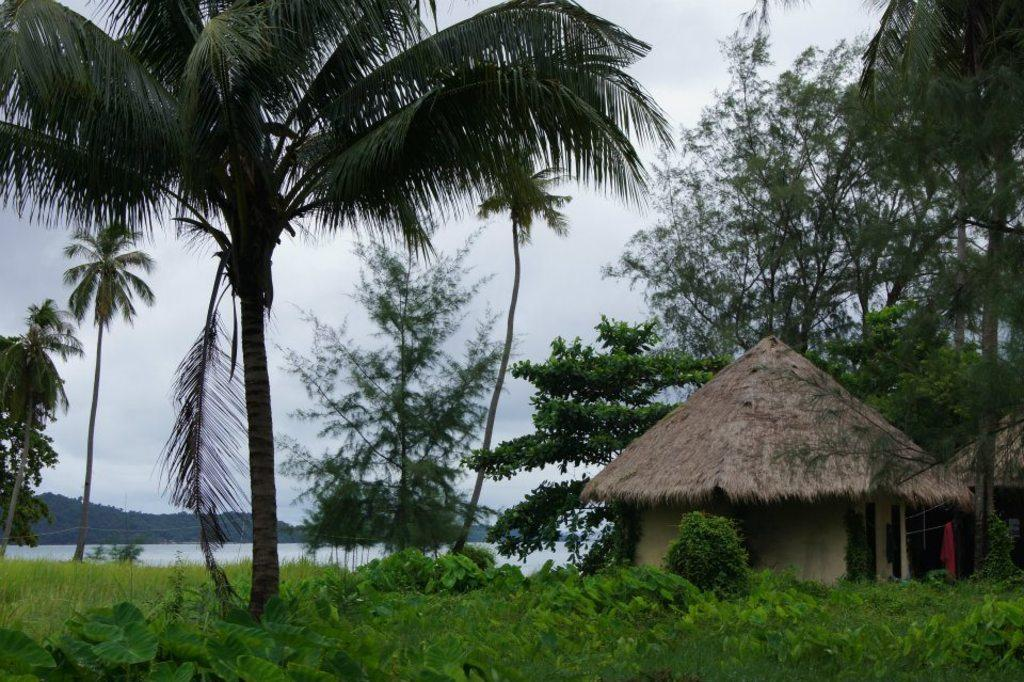What type of natural elements can be seen in the image? There are trees, plants, grass, water, and a cloudy sky visible in the image. What is the ground covered with in the image? The ground is covered with grass in the image. Can you describe the water in the image? The water is visible in the image, but its specific location or form is not mentioned. What type of vegetation is present in the image? Trees and plants are present in the image. Reasoning: Let' Let's think step by step in order to produce the conversation. We start by identifying the main natural elements in the image, which include trees, plants, grass, water, and the sky. Then, we focus on the ground and describe its coverage, which is grass. Finally, we mention the water and its presence in the image, without specifying its form or location. Absurd Question/Answer: How many quills are sticking out of the trees in the image? There are no quills present in the image; it features trees, plants, grass, water, and a cloudy sky. 